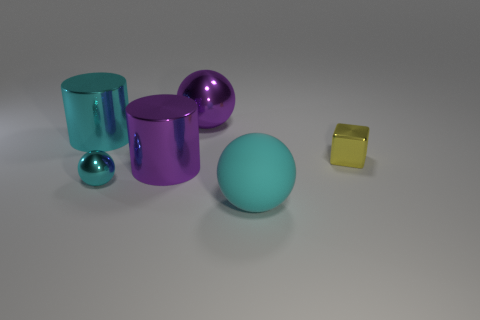How many things are either purple metal cylinders or large things that are on the left side of the purple shiny cylinder?
Your answer should be very brief. 2. There is a thing that is in front of the tiny metal sphere; is its shape the same as the small metal object on the left side of the matte ball?
Offer a terse response. Yes. Are there any other things that have the same color as the tiny metallic block?
Offer a terse response. No. There is a small object that is the same material as the tiny cyan sphere; what shape is it?
Your response must be concise. Cube. What is the big object that is to the left of the large cyan sphere and in front of the cyan metal cylinder made of?
Keep it short and to the point. Metal. Is the color of the tiny ball the same as the matte ball?
Provide a succinct answer. Yes. What shape is the large object that is the same color as the large rubber sphere?
Make the answer very short. Cylinder. What number of other yellow things are the same shape as the rubber thing?
Make the answer very short. 0. What size is the purple cylinder that is the same material as the cube?
Ensure brevity in your answer.  Large. Do the yellow shiny block and the matte thing have the same size?
Your response must be concise. No. 